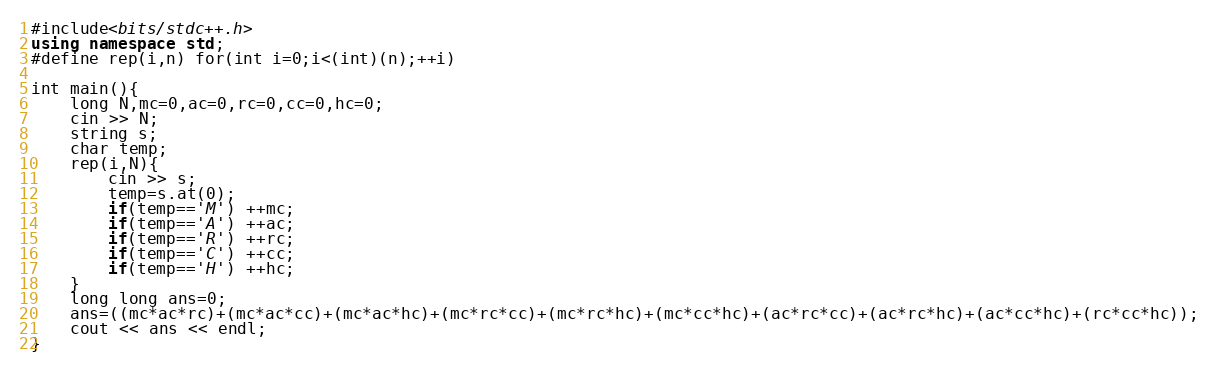Convert code to text. <code><loc_0><loc_0><loc_500><loc_500><_C++_>#include<bits/stdc++.h>
using namespace std;
#define rep(i,n) for(int i=0;i<(int)(n);++i)

int main(){
    long N,mc=0,ac=0,rc=0,cc=0,hc=0;
    cin >> N;
    string s;
    char temp;
    rep(i,N){
        cin >> s;
        temp=s.at(0);
        if(temp=='M') ++mc;
        if(temp=='A') ++ac;
        if(temp=='R') ++rc;
        if(temp=='C') ++cc;
        if(temp=='H') ++hc;
    }
    long long ans=0;
    ans=((mc*ac*rc)+(mc*ac*cc)+(mc*ac*hc)+(mc*rc*cc)+(mc*rc*hc)+(mc*cc*hc)+(ac*rc*cc)+(ac*rc*hc)+(ac*cc*hc)+(rc*cc*hc));
    cout << ans << endl;
}</code> 